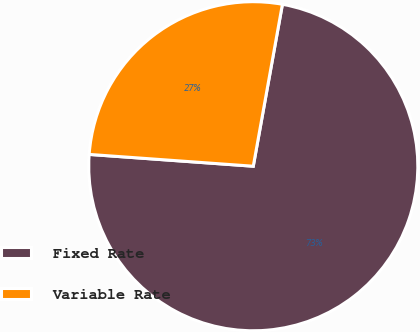<chart> <loc_0><loc_0><loc_500><loc_500><pie_chart><fcel>Fixed Rate<fcel>Variable Rate<nl><fcel>73.31%<fcel>26.69%<nl></chart> 